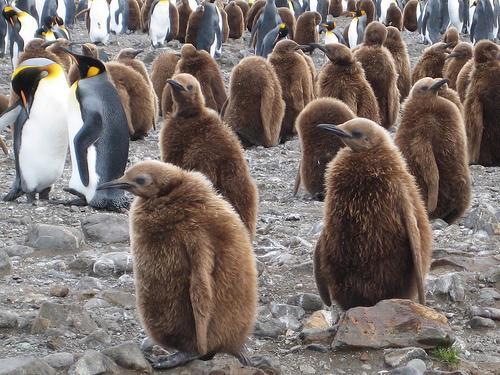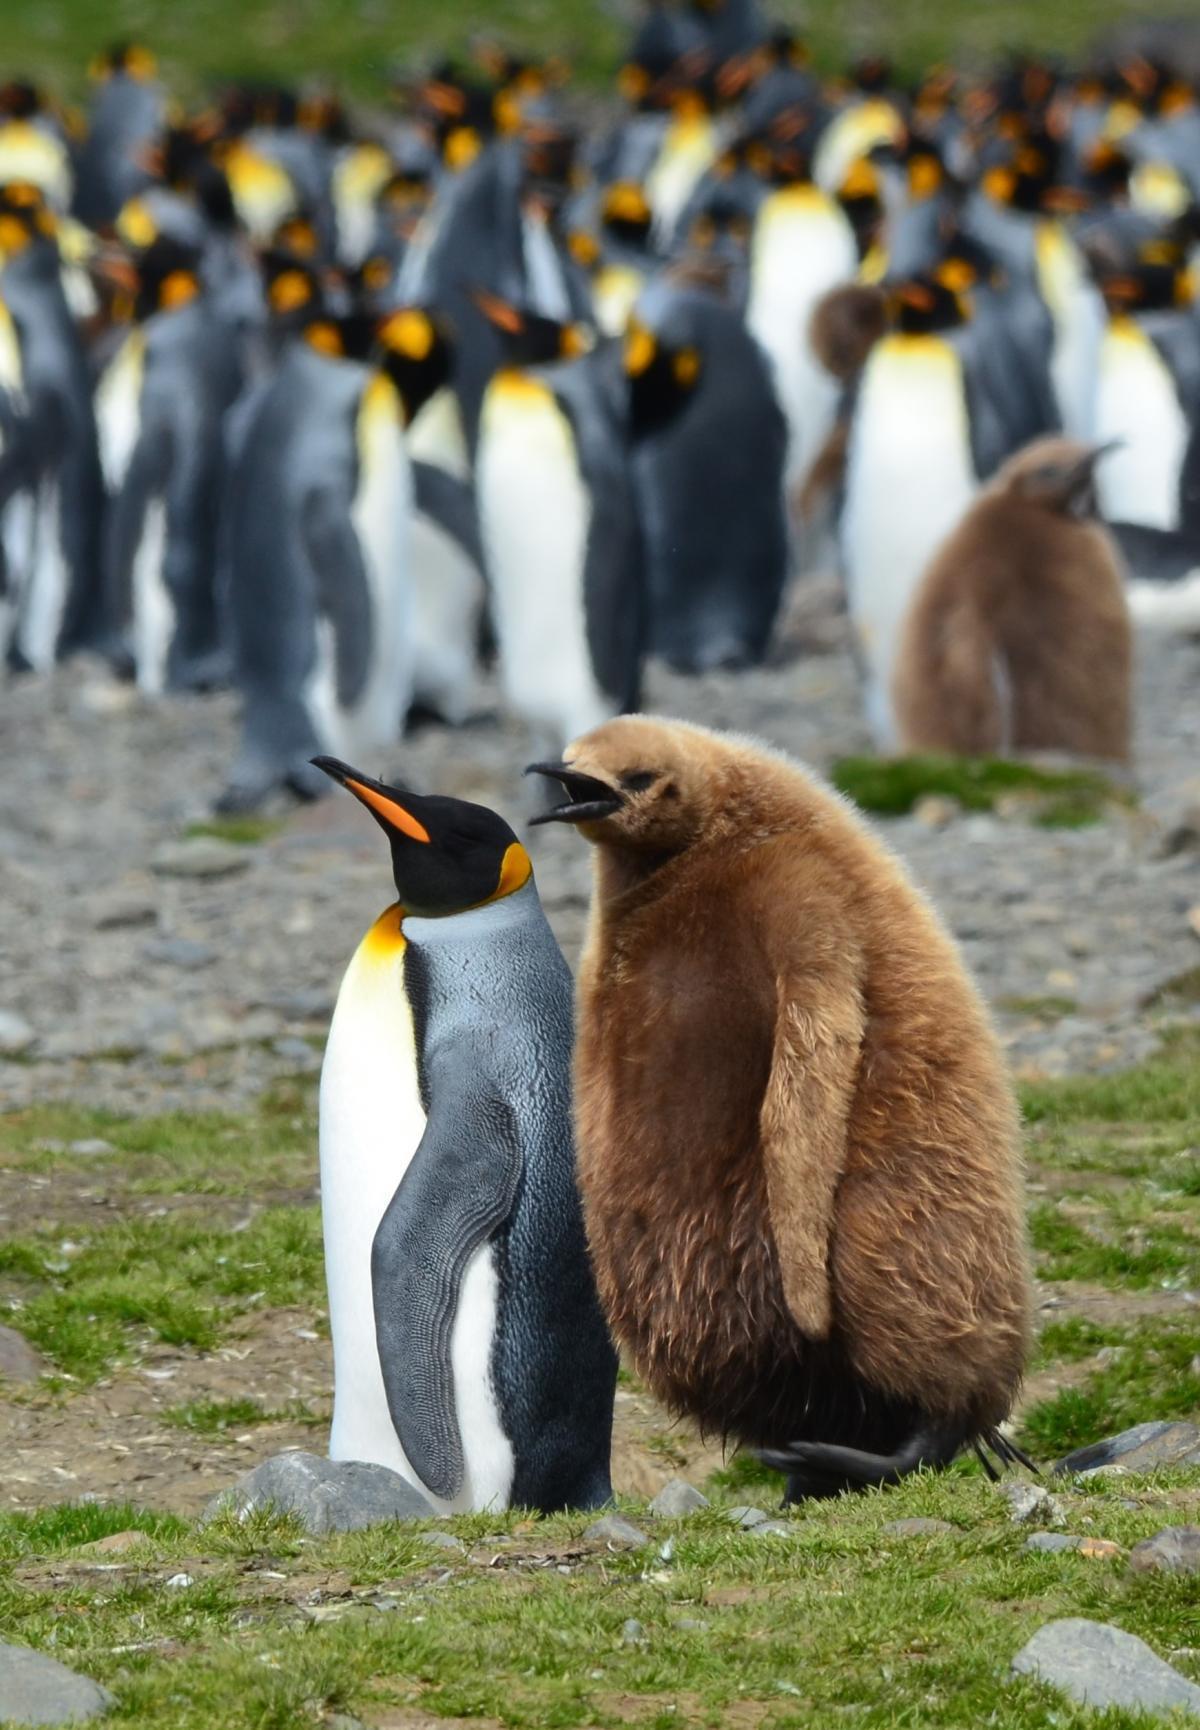The first image is the image on the left, the second image is the image on the right. For the images displayed, is the sentence "In the right image, a fuzzy brown penguin stands by itself, with other penguins in the background." factually correct? Answer yes or no. No. The first image is the image on the left, the second image is the image on the right. For the images shown, is this caption "One of the images contains visible grass." true? Answer yes or no. Yes. 